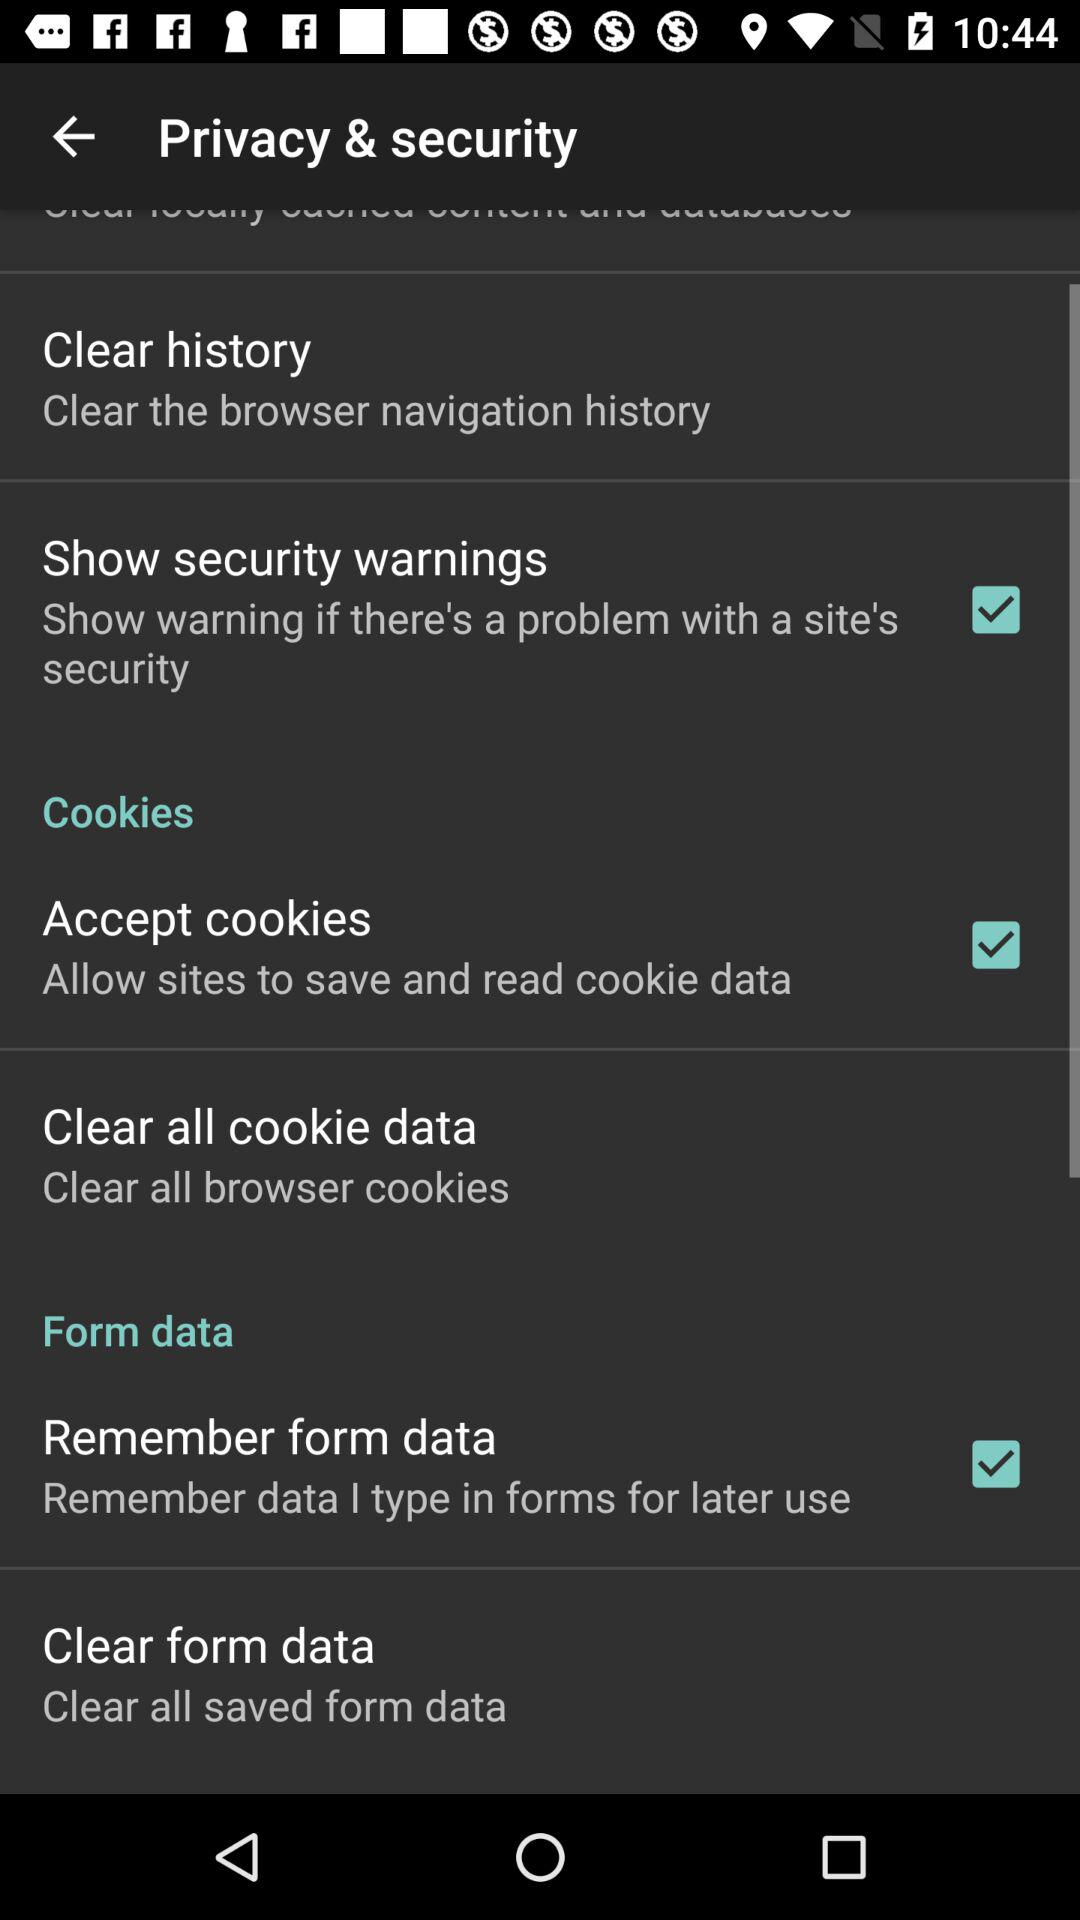What is the current status of "Remember form data"? The status is "on". 